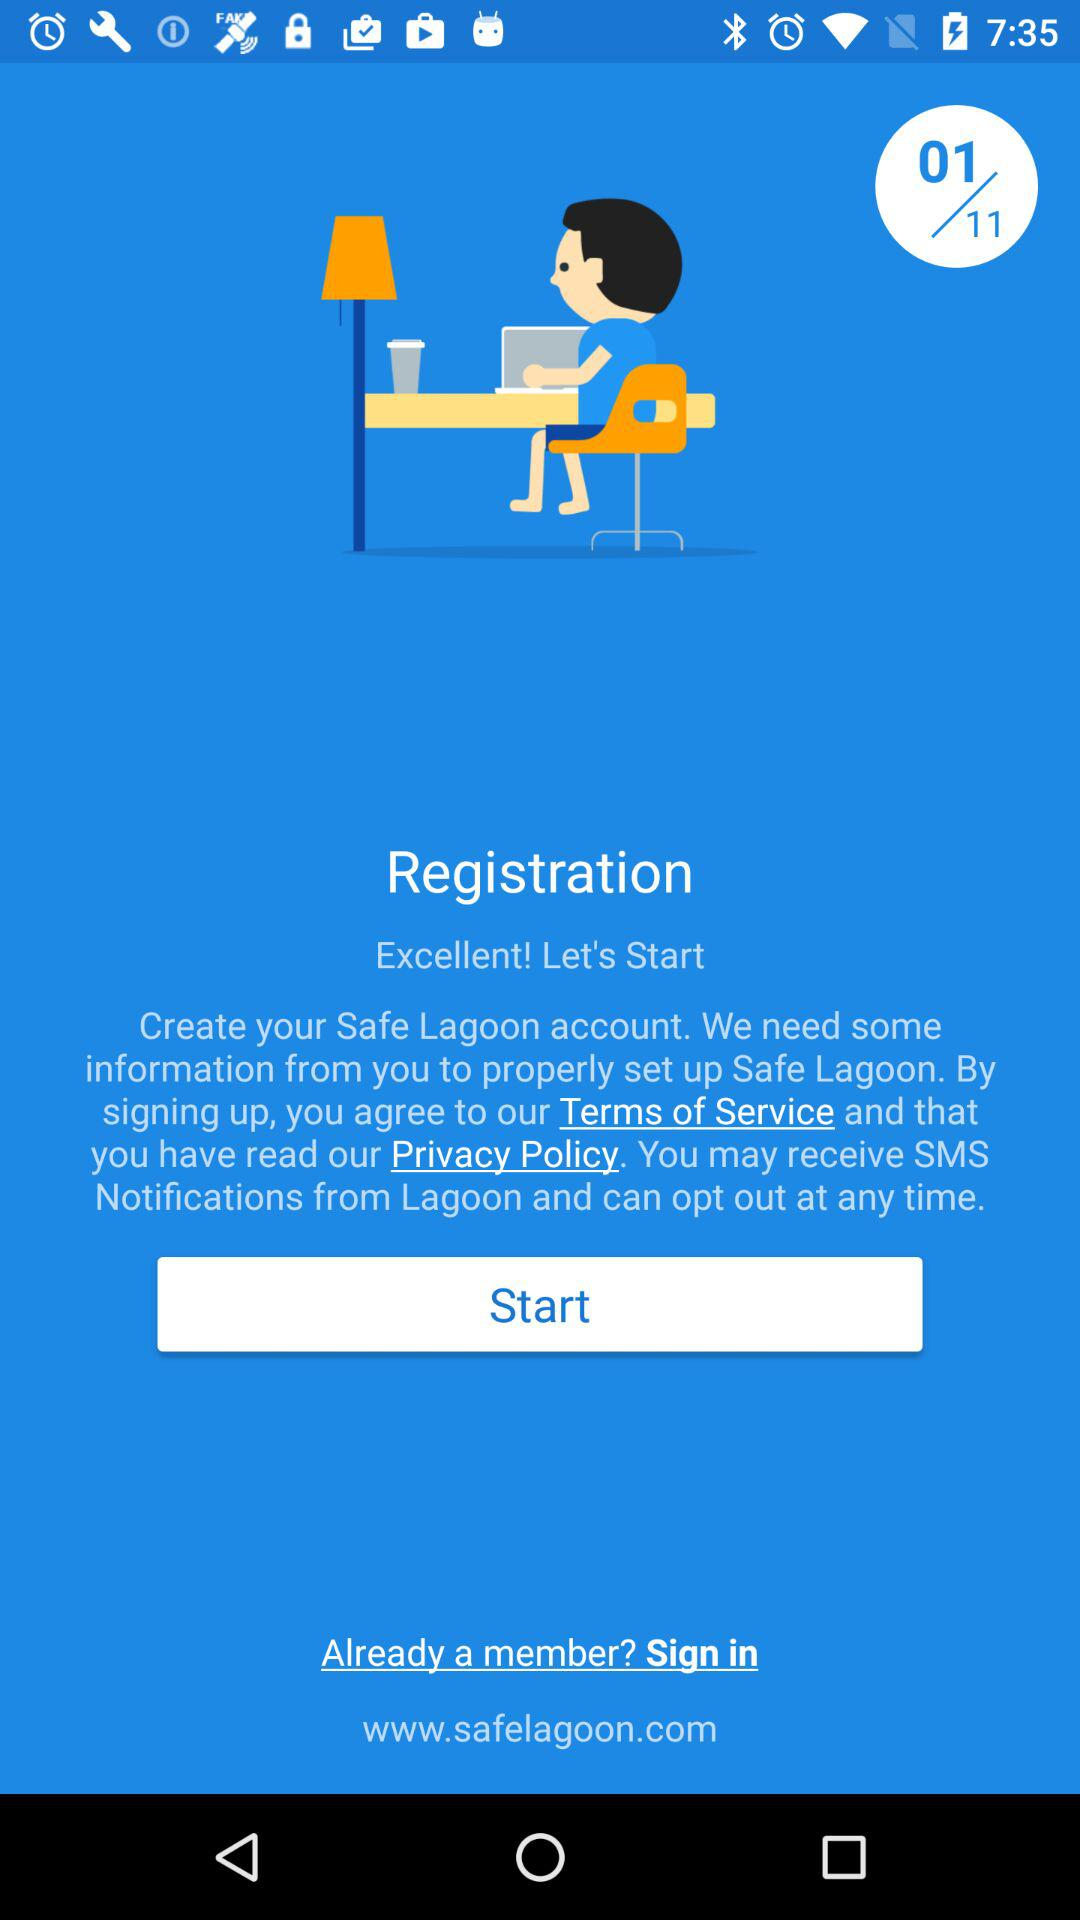How many pages in total are there in the application? There are 11 pages in total in the application. 